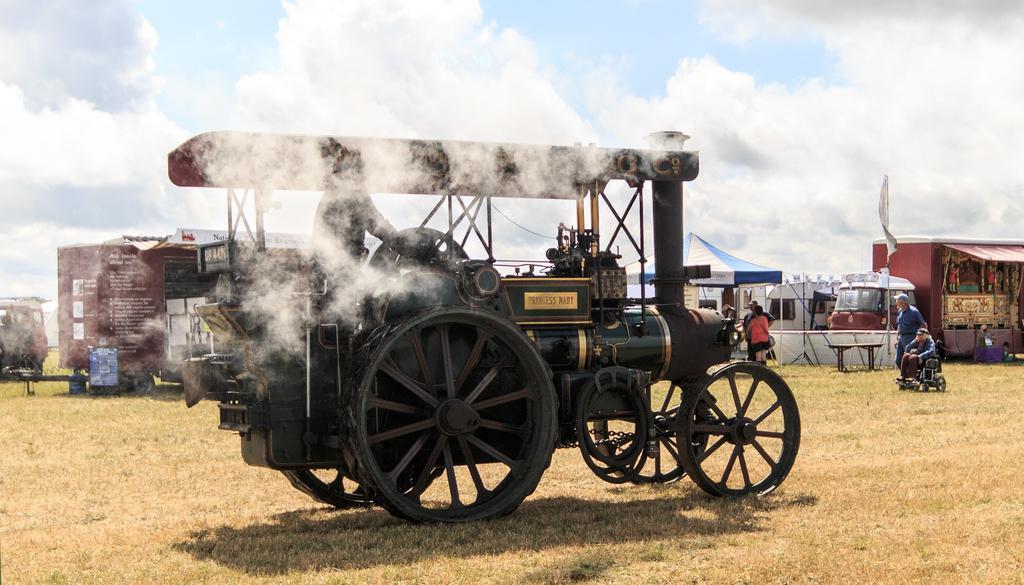Describe this image in one or two sentences. In this image I can see a vehicle which is green, black and cream in color and I can see smoke and the ground. I can see some grass, few persons standing, a person sitting in a wheel chair, few other vehicles, a store, a tent and the sky. 